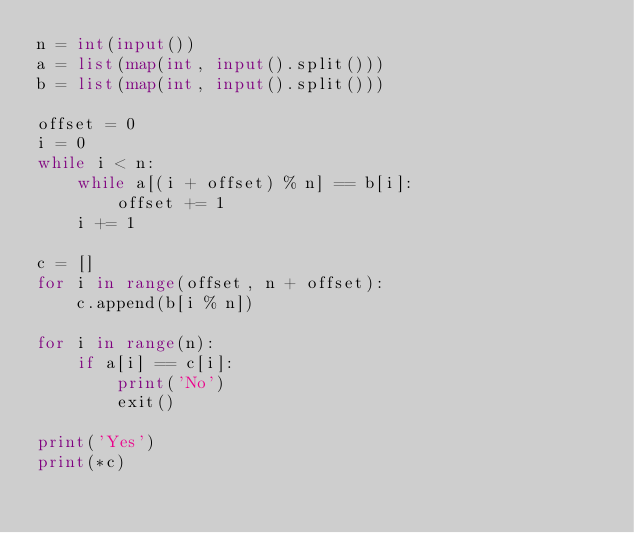<code> <loc_0><loc_0><loc_500><loc_500><_Python_>n = int(input())
a = list(map(int, input().split()))
b = list(map(int, input().split()))

offset = 0
i = 0
while i < n:
    while a[(i + offset) % n] == b[i]:
        offset += 1
    i += 1

c = []
for i in range(offset, n + offset):
    c.append(b[i % n])

for i in range(n):
    if a[i] == c[i]:
        print('No')
        exit()

print('Yes')
print(*c)
</code> 